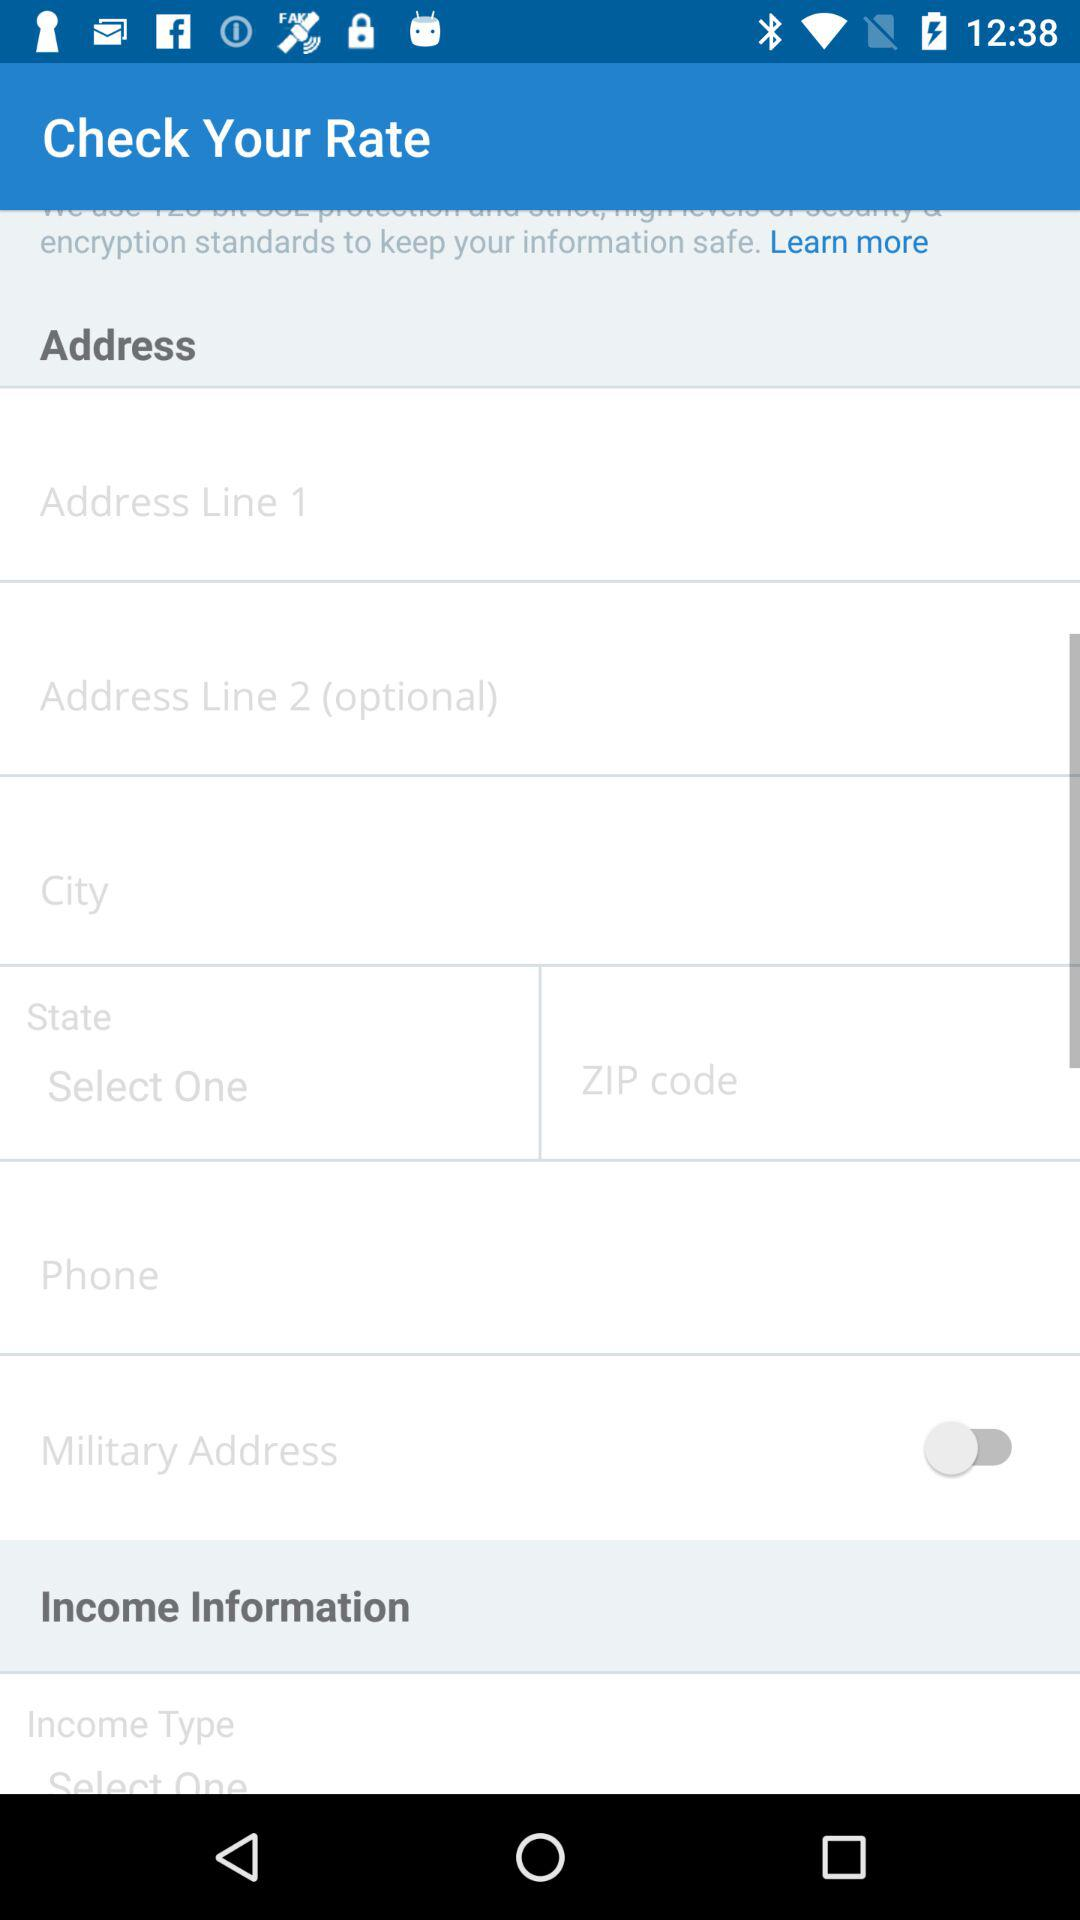How many address lines can be entered?
Answer the question using a single word or phrase. 2 